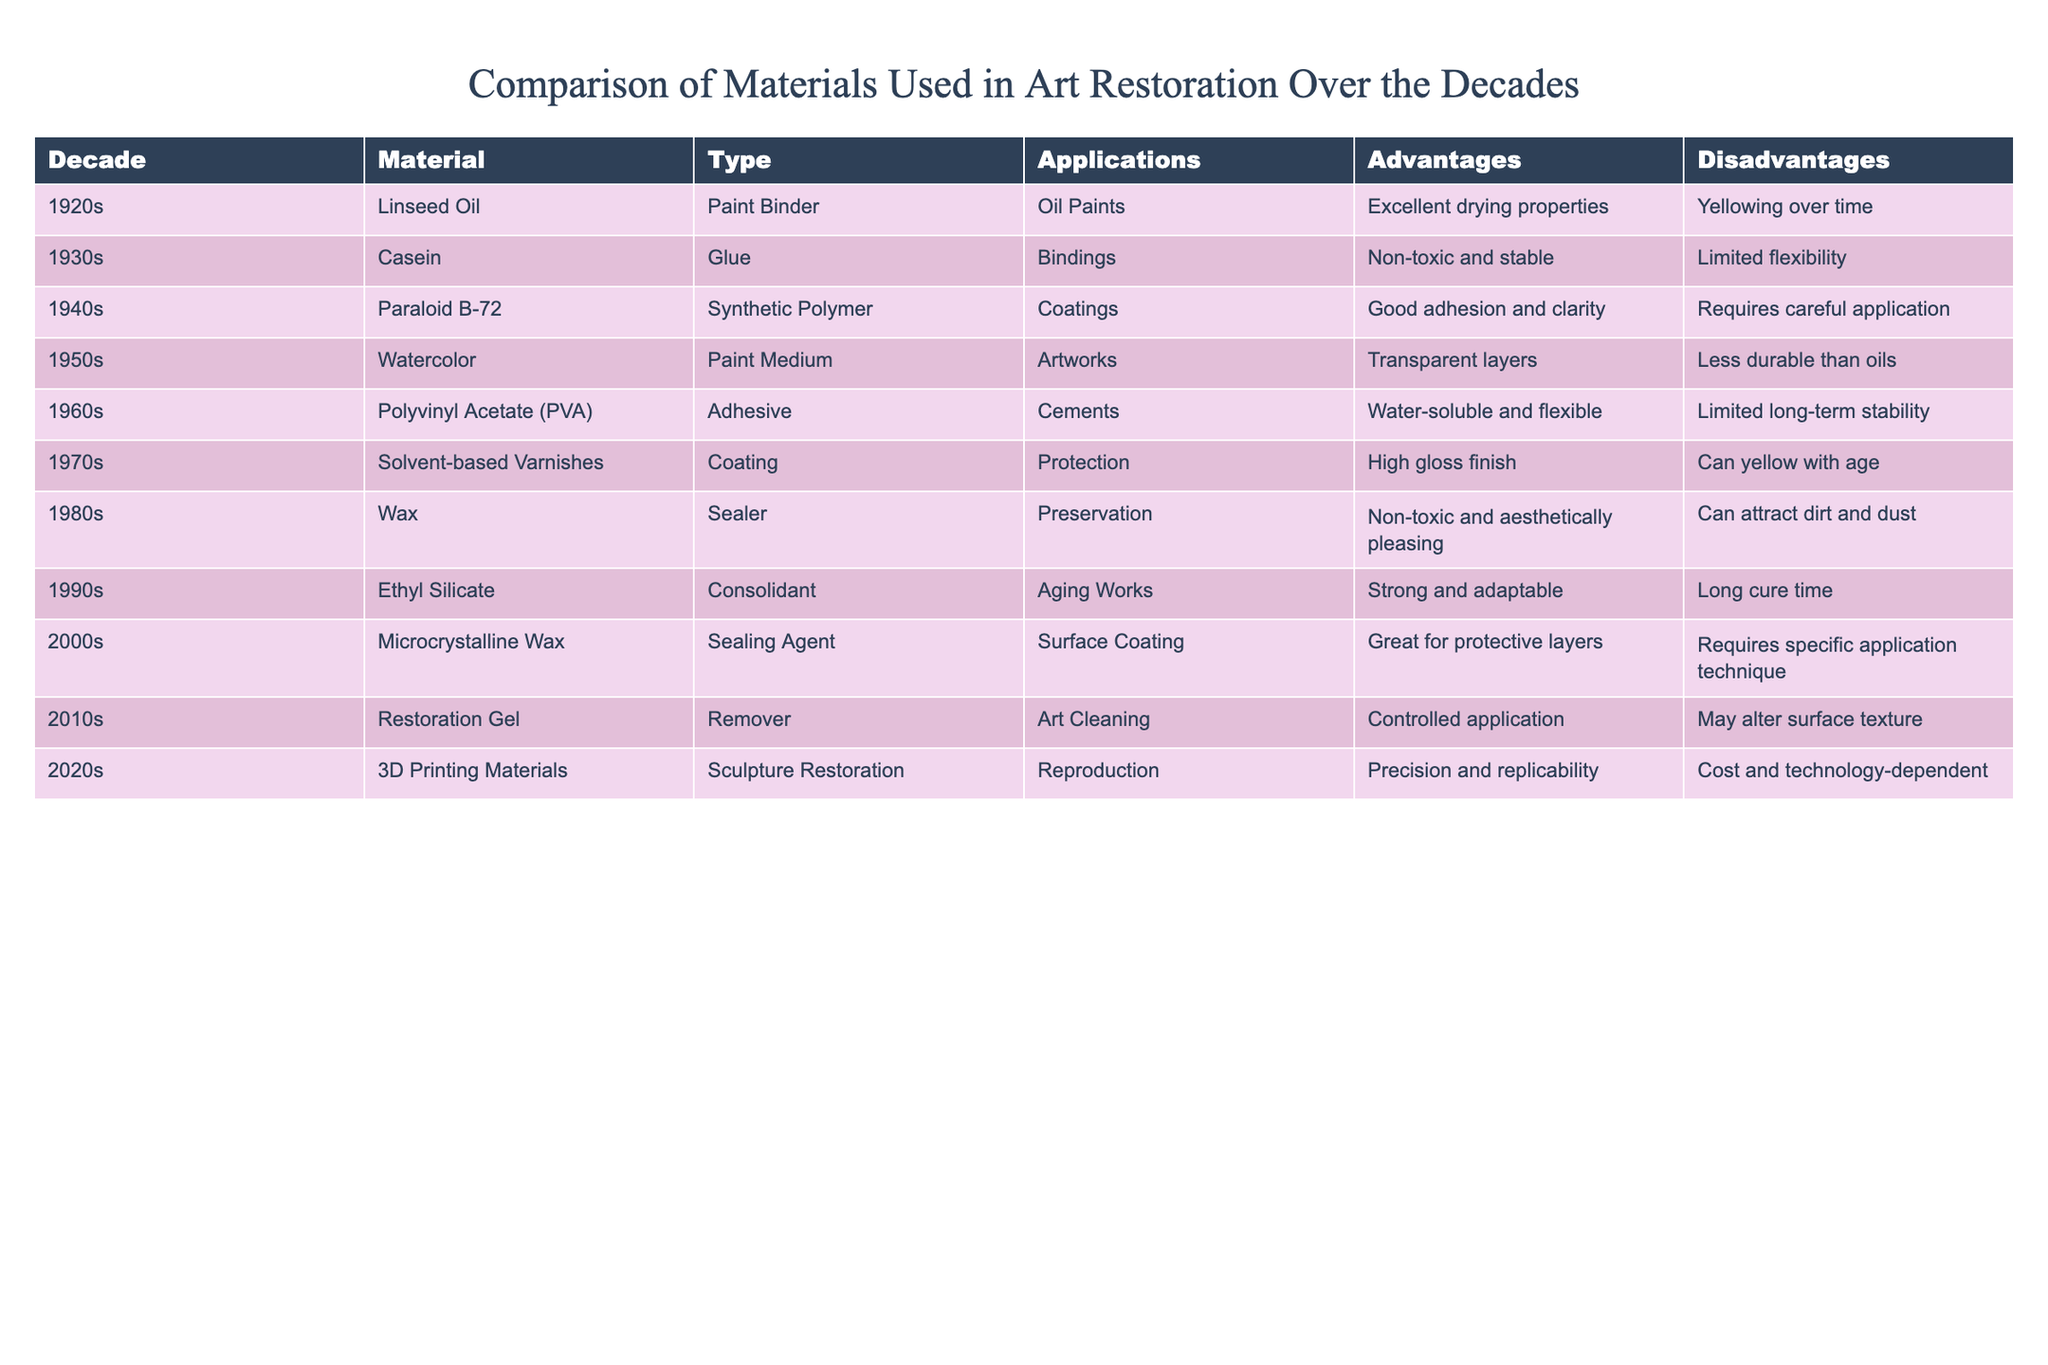What material was predominantly used in the 1940s for coatings? In the table, under the decade of the 1940s, the material listed for coatings is Paraloid B-72.
Answer: Paraloid B-72 Which decade saw the introduction of 3D printing materials in art restoration? The table indicates that 3D printing materials were introduced in the 2020s.
Answer: 2020s What is a common disadvantage of both linseed oil and solvent-based varnishes? By examining the materials and their disadvantages, both linseed oil and solvent-based varnishes have yellowing over time as a common drawback.
Answer: Yellowing over time Which material listed has flexibility as one of its advantages? The 1960s material, Polyvinyl Acetate (PVA), is mentioned as having water-soluble and flexible properties, making it standout for flexibility.
Answer: Polyvinyl Acetate (PVA) Count how many materials listed were adhesives and identify them. Analyzing the table, there are two adhesives: Casein from the 1930s and Polyvinyl Acetate (PVA) from the 1960s, totaling two materials.
Answer: Two materials Which decade had the longest cure time for a consolidant? According to the table, the 1990s had Ethyl Silicate with a long cure time, which is the only mention of cure time length, indicating that it's the longest listed.
Answer: 1990s What percentage of the materials listed are from the 2000s and later? There are four materials from the 2000s and later (2000s and 2010s and 2020s), while a total of ten materials are in the table. (4/10) * 100 = 40%.
Answer: 40% What is the primary application of wax as mentioned in the table? The table states that wax is used primarily for preservation purposes in the 1980s.
Answer: Preservation Is it true that all the materials listed have their own specific application techniques? Reviewing the table, most materials mention a specific application technique; however, not all of them explicitly state this, thus making the statement false.
Answer: False If you wanted to identify the material with the best adhesion properties, which one would you choose? The table indicates that the material with good adhesion is Paraloid B-72 from the 1940s; therefore, this would be the best choice for adhesion.
Answer: Paraloid B-72 